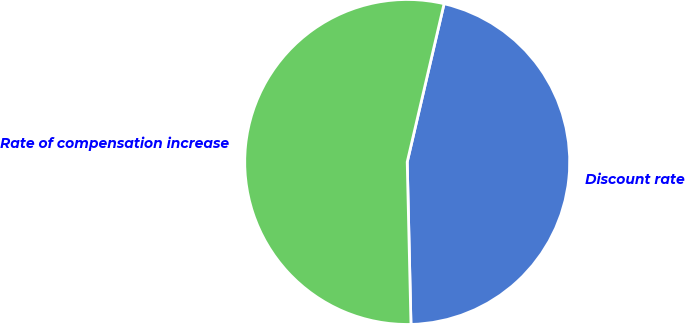Convert chart to OTSL. <chart><loc_0><loc_0><loc_500><loc_500><pie_chart><fcel>Discount rate<fcel>Rate of compensation increase<nl><fcel>45.99%<fcel>54.01%<nl></chart> 